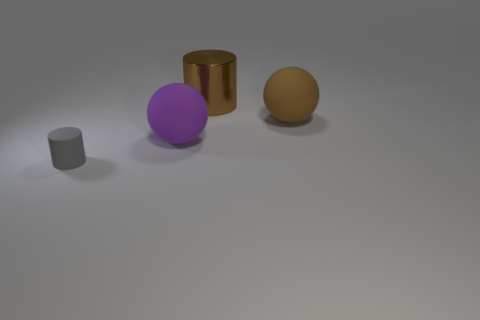Add 3 rubber balls. How many objects exist? 7 Subtract all gray matte cylinders. Subtract all metal things. How many objects are left? 2 Add 1 tiny matte objects. How many tiny matte objects are left? 2 Add 1 metallic things. How many metallic things exist? 2 Subtract 1 gray cylinders. How many objects are left? 3 Subtract all green cylinders. Subtract all green blocks. How many cylinders are left? 2 